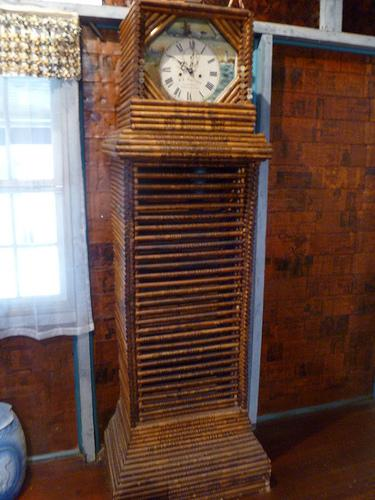Question: who is next to the clock?
Choices:
A. A woman.
B. A man.
C. A little girl.
D. Nobody.
Answer with the letter. Answer: D Question: what color is it?
Choices:
A. Brown.
B. Green.
C. White.
D. Black.
Answer with the letter. Answer: A 